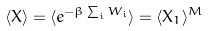<formula> <loc_0><loc_0><loc_500><loc_500>\langle X \rangle = \langle e ^ { - \beta \sum _ { i } W _ { i } } \rangle = \langle X _ { 1 } \rangle ^ { M }</formula> 